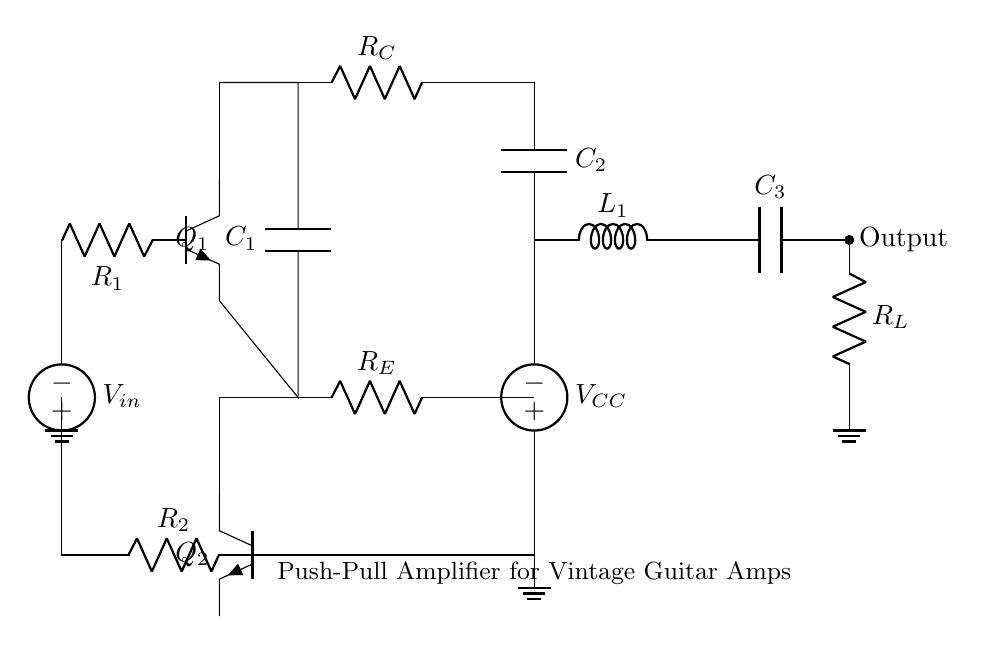What type of amplifier is shown in the circuit? The circuit is labeled as a "Push-Pull Amplifier," which is a specific configuration commonly used for audio amplification.
Answer: Push-Pull Amplifier How many transistors are used in this circuit? There are two transistors shown in the circuit diagram, labeled as Q1 and Q2.
Answer: Two What does R1 represent in the circuit? R1 is identified as a resistor, specifically connected to the base of transistor Q1, influencing its biasing and input impedance.
Answer: Resistor What is the function of the capacitor C1 in this circuit? The capacitor C1 is connected in a way that it couples the AC signal to the base of Q1 while blocking DC, essential for amplification.
Answer: Coupling Capacitor Explain how the output is taken in the circuit. The output is taken across the load resistor R_L, connected at the output node beside the inductor L1 and capacitor C3, which can provide a stabilized voltage output.
Answer: Across R_L What is the purpose of the voltage source V_CC in the circuit? The voltage source V_CC provides the necessary supply voltage for the transistors Q1 and Q2, allowing them to operate in their active region for amplification duties.
Answer: Supply Voltage What role does the inductor L1 play in this amplifier circuit? The inductor L1 is part of the output stage, typically used for filtering and controlling the frequency response, enhancing the output signal characteristics.
Answer: Filtering Component 